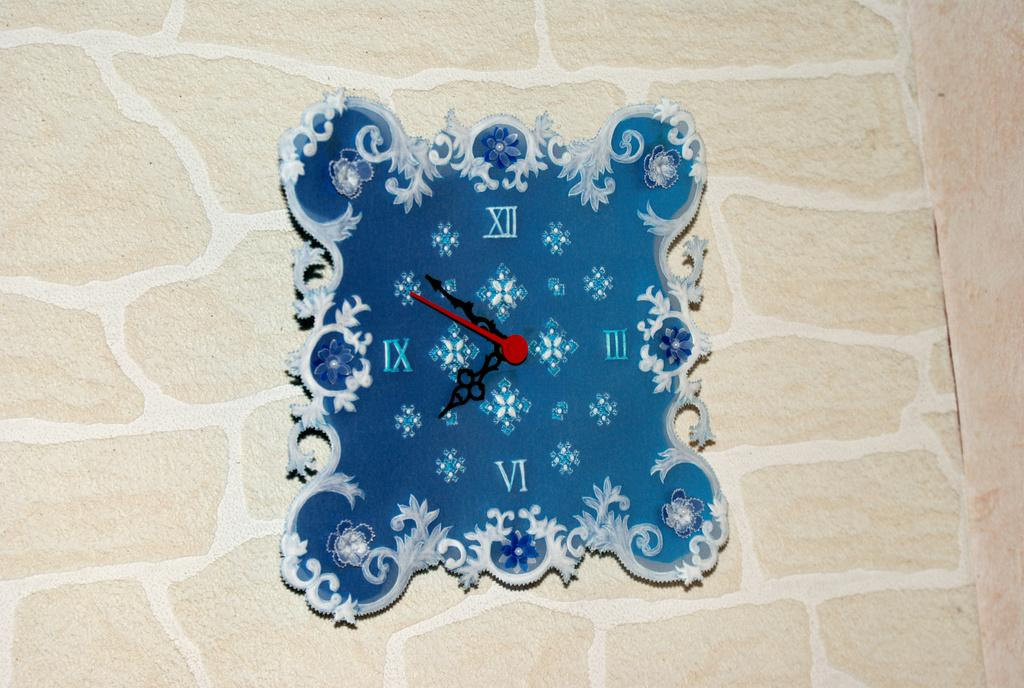<image>
Describe the image concisely. A clock with  a blue background is depicting the time as about 7:51. 